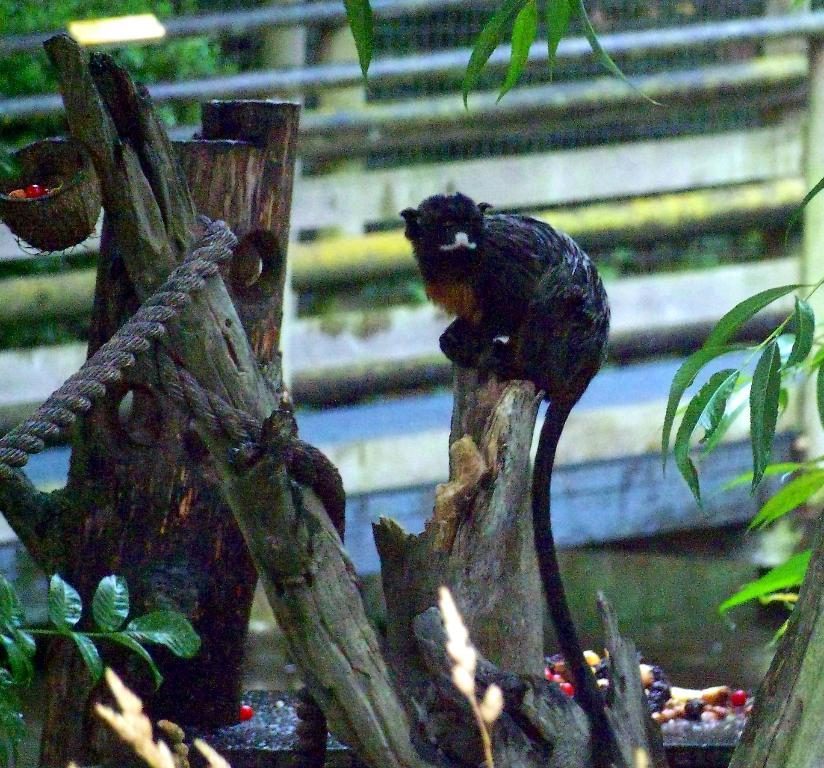What is the main subject of the image? There is an animal sitting on a tree trunk in the image. How many tree trunks are visible in the image? There are two other tree trunks in the image. Can you describe the background of the image? The background of the image is blurred. What type of story is the animal telling from the tree trunk? There is no indication in the image that the animal is telling a story, as it is simply sitting on the tree trunk. 